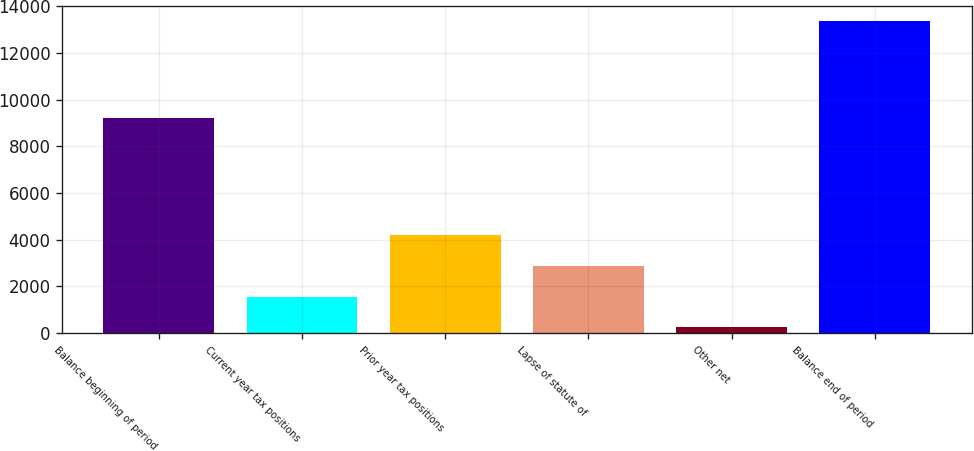Convert chart to OTSL. <chart><loc_0><loc_0><loc_500><loc_500><bar_chart><fcel>Balance beginning of period<fcel>Current year tax positions<fcel>Prior year tax positions<fcel>Lapse of statute of<fcel>Other net<fcel>Balance end of period<nl><fcel>9195<fcel>1565.6<fcel>4184.8<fcel>2875.2<fcel>256<fcel>13352<nl></chart> 